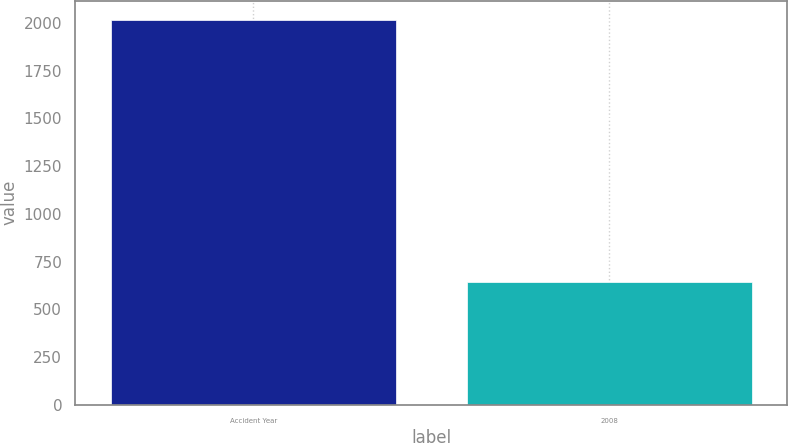Convert chart to OTSL. <chart><loc_0><loc_0><loc_500><loc_500><bar_chart><fcel>Accident Year<fcel>2008<nl><fcel>2015<fcel>643<nl></chart> 